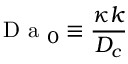Convert formula to latex. <formula><loc_0><loc_0><loc_500><loc_500>D a _ { 0 } \equiv \frac { \kappa k } { D _ { c } }</formula> 